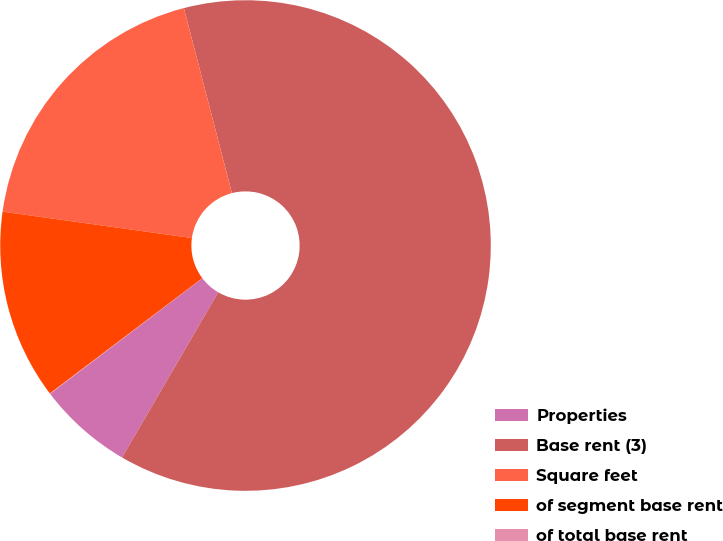Convert chart. <chart><loc_0><loc_0><loc_500><loc_500><pie_chart><fcel>Properties<fcel>Base rent (3)<fcel>Square feet<fcel>of segment base rent<fcel>of total base rent<nl><fcel>6.27%<fcel>62.43%<fcel>18.75%<fcel>12.51%<fcel>0.03%<nl></chart> 